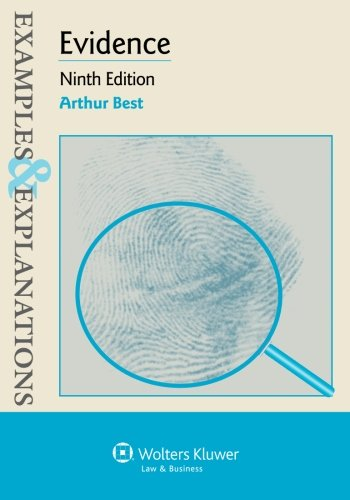Could this book be useful for those studying for the bar examination? Absolutely, this book serves as an invaluable resource for law students, particularly those preparing for the bar exam, as it breaks down complex legal concepts into comprehensible examples and explanations. 